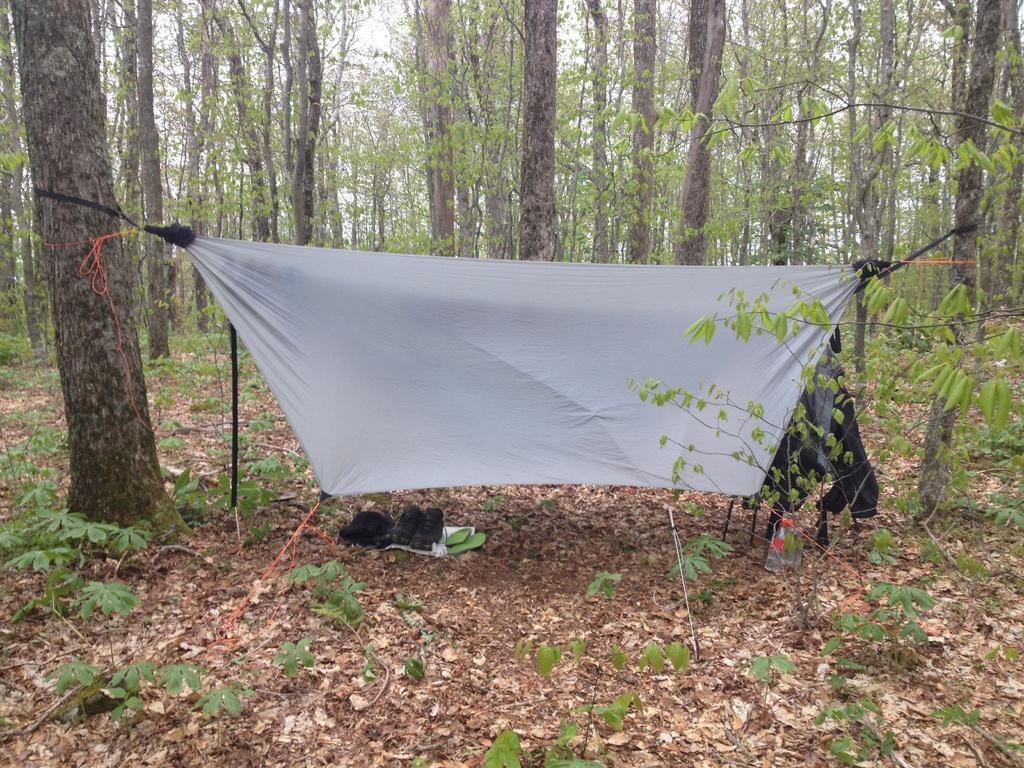In one or two sentences, can you explain what this image depicts? In this image I can see a white colour cloth, black shoes, a bottle and few black colour things. I can also see number of trees in the background. 